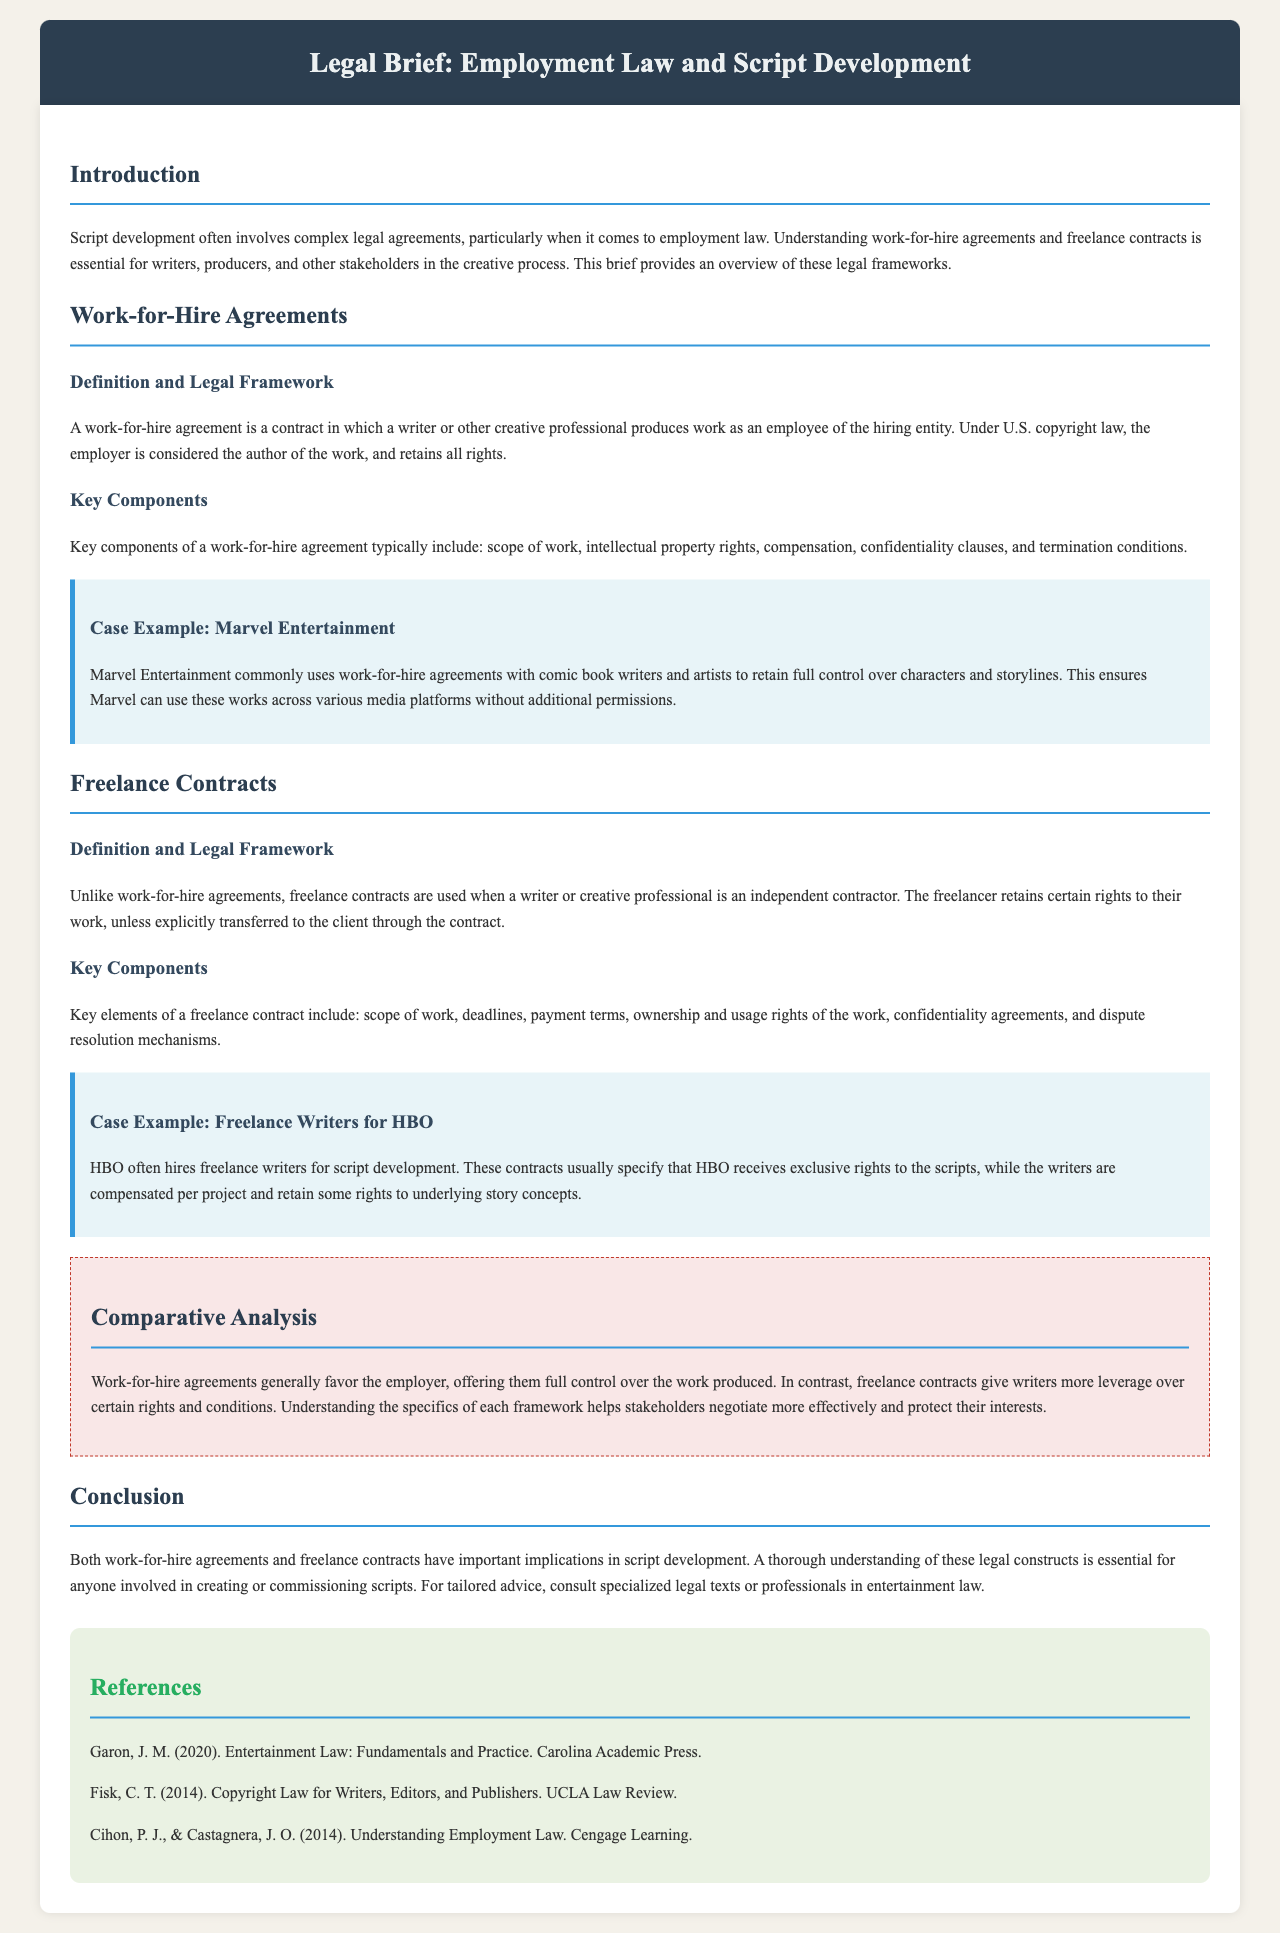What is a work-for-hire agreement? A work-for-hire agreement is a contract in which a writer or other creative professional produces work as an employee of the hiring entity.
Answer: A contract in which a writer or other creative professional produces work as an employee of the hiring entity What are key components of a freelance contract? Key elements of a freelance contract include: scope of work, deadlines, payment terms, ownership and usage rights of the work, confidentiality agreements, and dispute resolution mechanisms.
Answer: Scope of work, deadlines, payment terms, ownership and usage rights, confidentiality agreements, dispute resolution mechanisms Who is considered the author of the work in a work-for-hire agreement? Under U.S. copyright law, the employer is considered the author of the work, and retains all rights.
Answer: The employer What is the purpose of a work-for-hire agreement according to the document? This ensures Marvel can use these works across various media platforms without additional permissions.
Answer: To retain full control over characters and storylines Which company commonly uses work-for-hire agreements? Marvel Entertainment commonly uses work-for-hire agreements with comic book writers and artists.
Answer: Marvel Entertainment What is the relationship between freelancers and clients in freelance contracts? The freelancer retains certain rights to their work, unless explicitly transferred to the client through the contract.
Answer: The freelancer retains certain rights What does the comparative analysis section highlight about work-for-hire and freelance contracts? Work-for-hire agreements generally favor the employer, offering them full control over the work produced.
Answer: Work-for-hire agreements generally favor the employer What year was the book "Copyright Law for Writers, Editors, and Publishers" published? The book "Copyright Law for Writers, Editors, and Publishers" was published in 2014.
Answer: 2014 